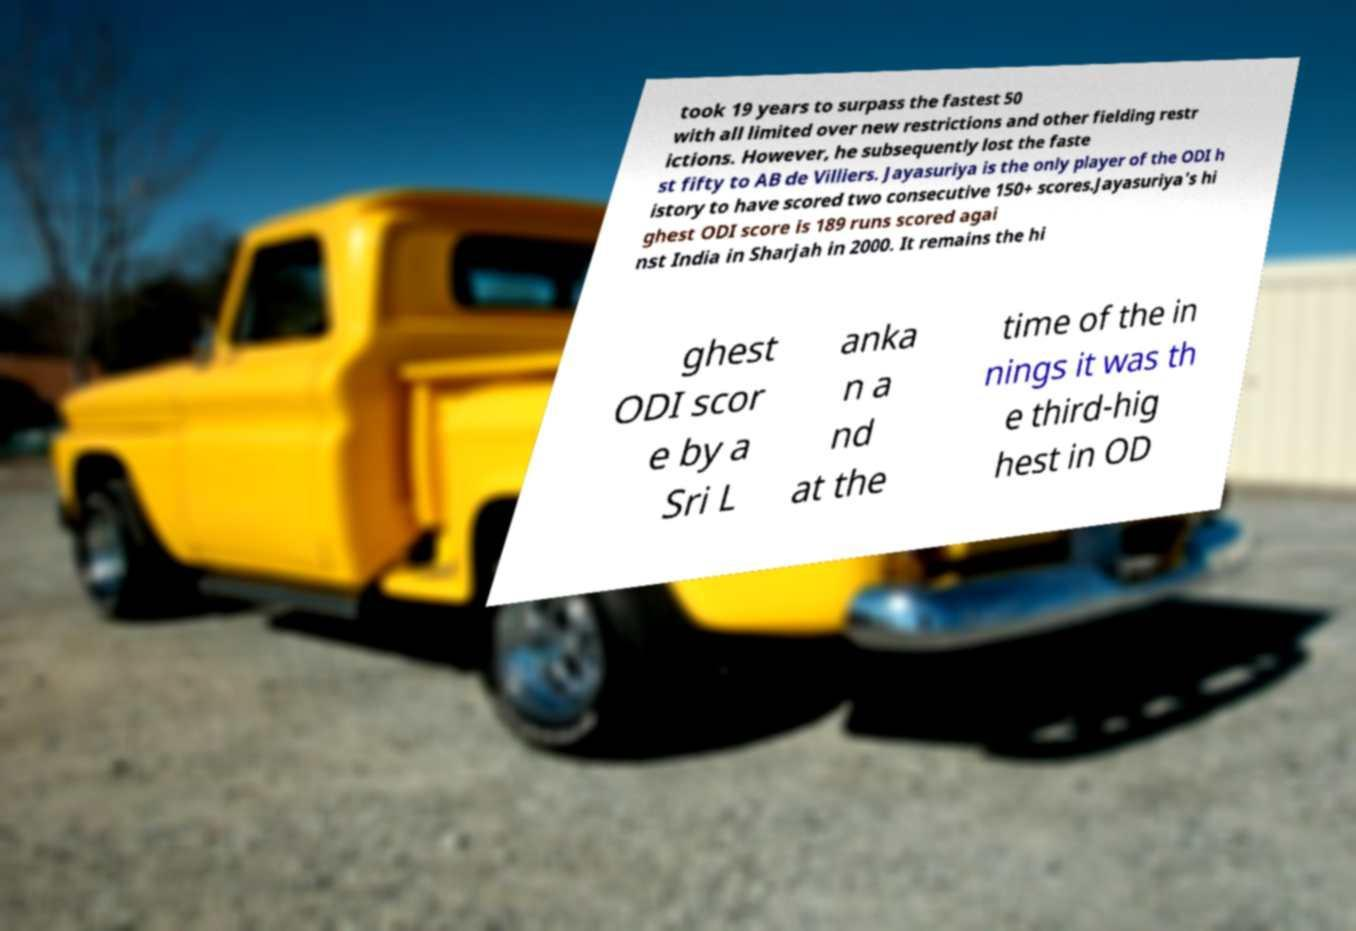Please read and relay the text visible in this image. What does it say? took 19 years to surpass the fastest 50 with all limited over new restrictions and other fielding restr ictions. However, he subsequently lost the faste st fifty to AB de Villiers. Jayasuriya is the only player of the ODI h istory to have scored two consecutive 150+ scores.Jayasuriya's hi ghest ODI score is 189 runs scored agai nst India in Sharjah in 2000. It remains the hi ghest ODI scor e by a Sri L anka n a nd at the time of the in nings it was th e third-hig hest in OD 